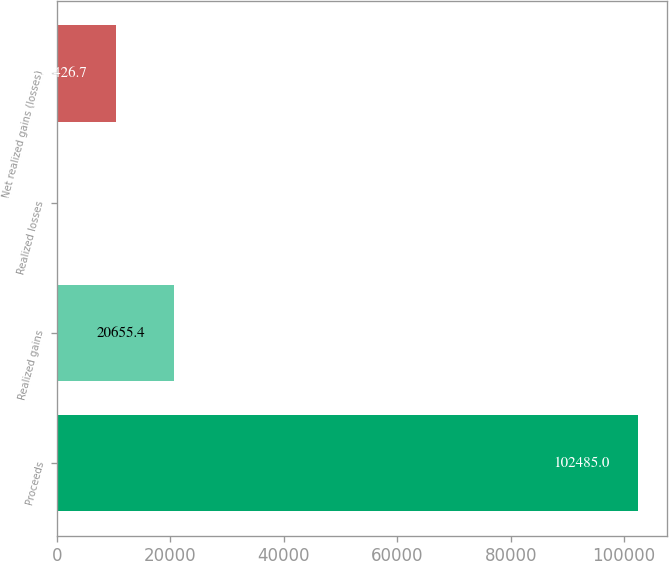Convert chart. <chart><loc_0><loc_0><loc_500><loc_500><bar_chart><fcel>Proceeds<fcel>Realized gains<fcel>Realized losses<fcel>Net realized gains (losses)<nl><fcel>102485<fcel>20655.4<fcel>198<fcel>10426.7<nl></chart> 